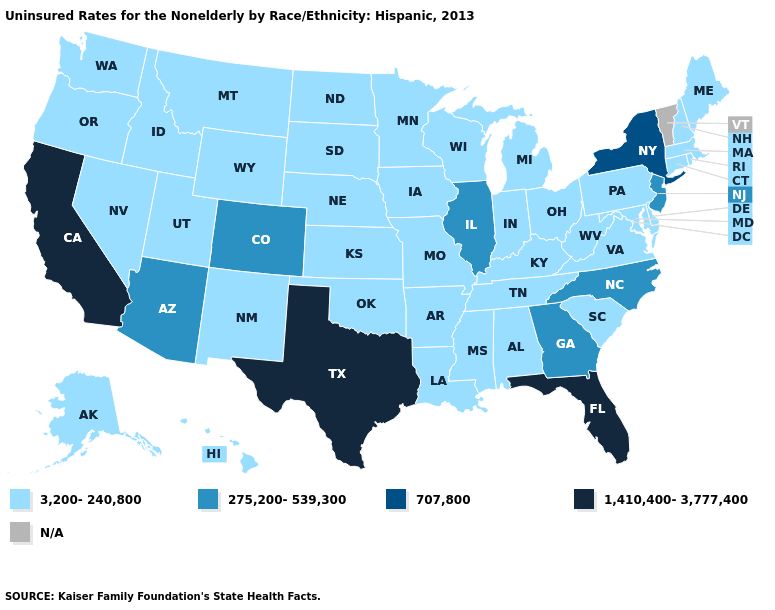Among the states that border Indiana , which have the highest value?
Answer briefly. Illinois. Name the states that have a value in the range 275,200-539,300?
Quick response, please. Arizona, Colorado, Georgia, Illinois, New Jersey, North Carolina. What is the lowest value in states that border Oregon?
Answer briefly. 3,200-240,800. What is the highest value in states that border Maryland?
Concise answer only. 3,200-240,800. What is the lowest value in the MidWest?
Concise answer only. 3,200-240,800. How many symbols are there in the legend?
Be succinct. 5. What is the lowest value in states that border Iowa?
Give a very brief answer. 3,200-240,800. What is the highest value in the MidWest ?
Quick response, please. 275,200-539,300. What is the highest value in the USA?
Be succinct. 1,410,400-3,777,400. What is the value of Maryland?
Short answer required. 3,200-240,800. Does the first symbol in the legend represent the smallest category?
Be succinct. Yes. Among the states that border Kentucky , which have the lowest value?
Give a very brief answer. Indiana, Missouri, Ohio, Tennessee, Virginia, West Virginia. Is the legend a continuous bar?
Short answer required. No. 